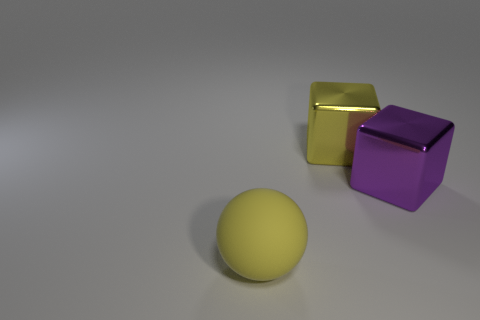Is the number of metal blocks to the right of the yellow metallic thing the same as the number of purple objects that are in front of the yellow sphere?
Offer a terse response. No. Are there more tiny blue rubber blocks than yellow metal things?
Ensure brevity in your answer.  No. How many shiny things are either yellow objects or purple objects?
Ensure brevity in your answer.  2. What number of big matte things have the same color as the matte ball?
Offer a terse response. 0. What is the material of the big yellow block that is behind the big shiny thing that is to the right of the yellow object on the right side of the big yellow sphere?
Give a very brief answer. Metal. What color is the metallic object to the left of the large cube that is to the right of the yellow block?
Provide a succinct answer. Yellow. How many large things are purple blocks or rubber cubes?
Offer a very short reply. 1. What number of large yellow things are the same material as the large yellow block?
Your answer should be compact. 0. What size is the yellow thing that is to the right of the large matte object?
Keep it short and to the point. Large. The object behind the large block in front of the yellow metal cube is what shape?
Your answer should be compact. Cube. 